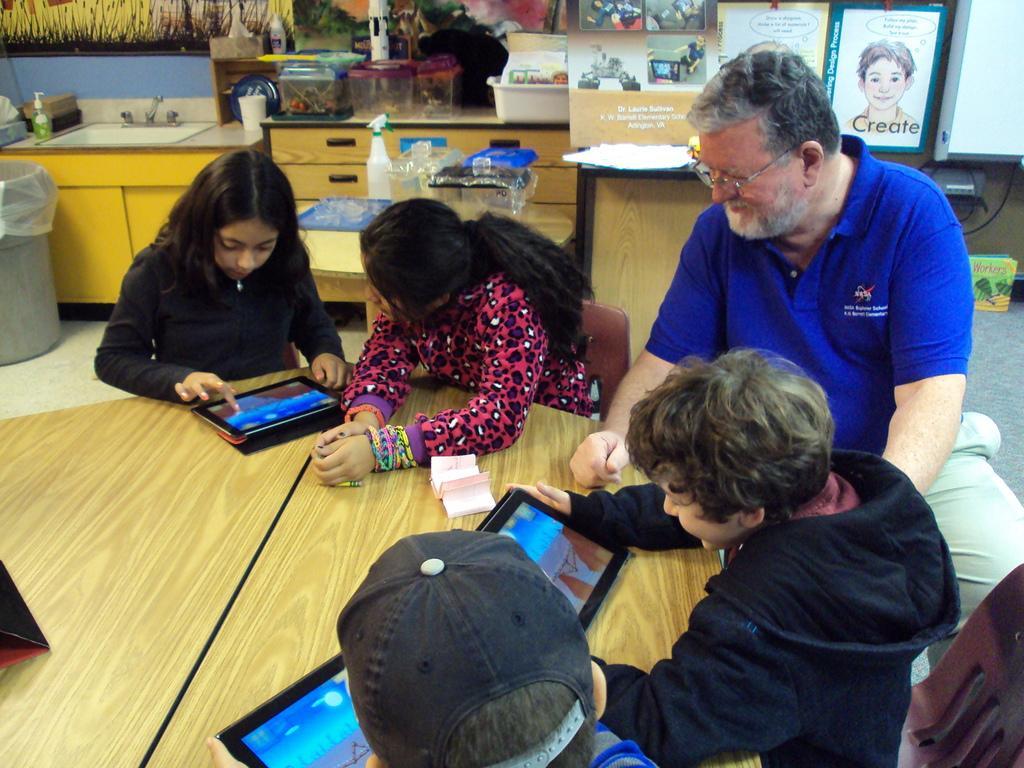Describe this image in one or two sentences. In this image we can see persons sitting around the table. On the table we can see tablets and papers. In the background we can see cupboards, sink, tap, bottles, glasses, spray bottle, containers, photo frames, books, television and wall. 